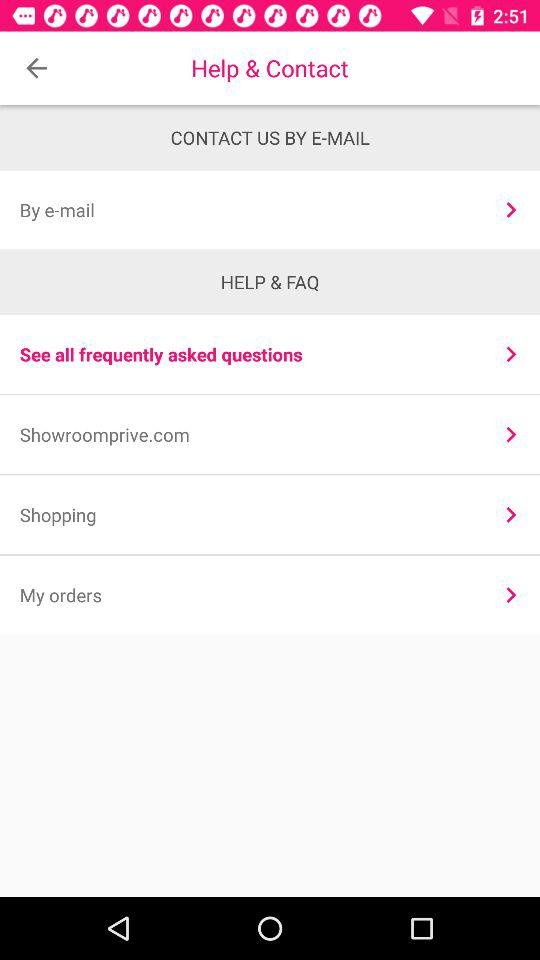Through what medium can we contact Showroomprive.com? You can connect through "E-MAIL". 